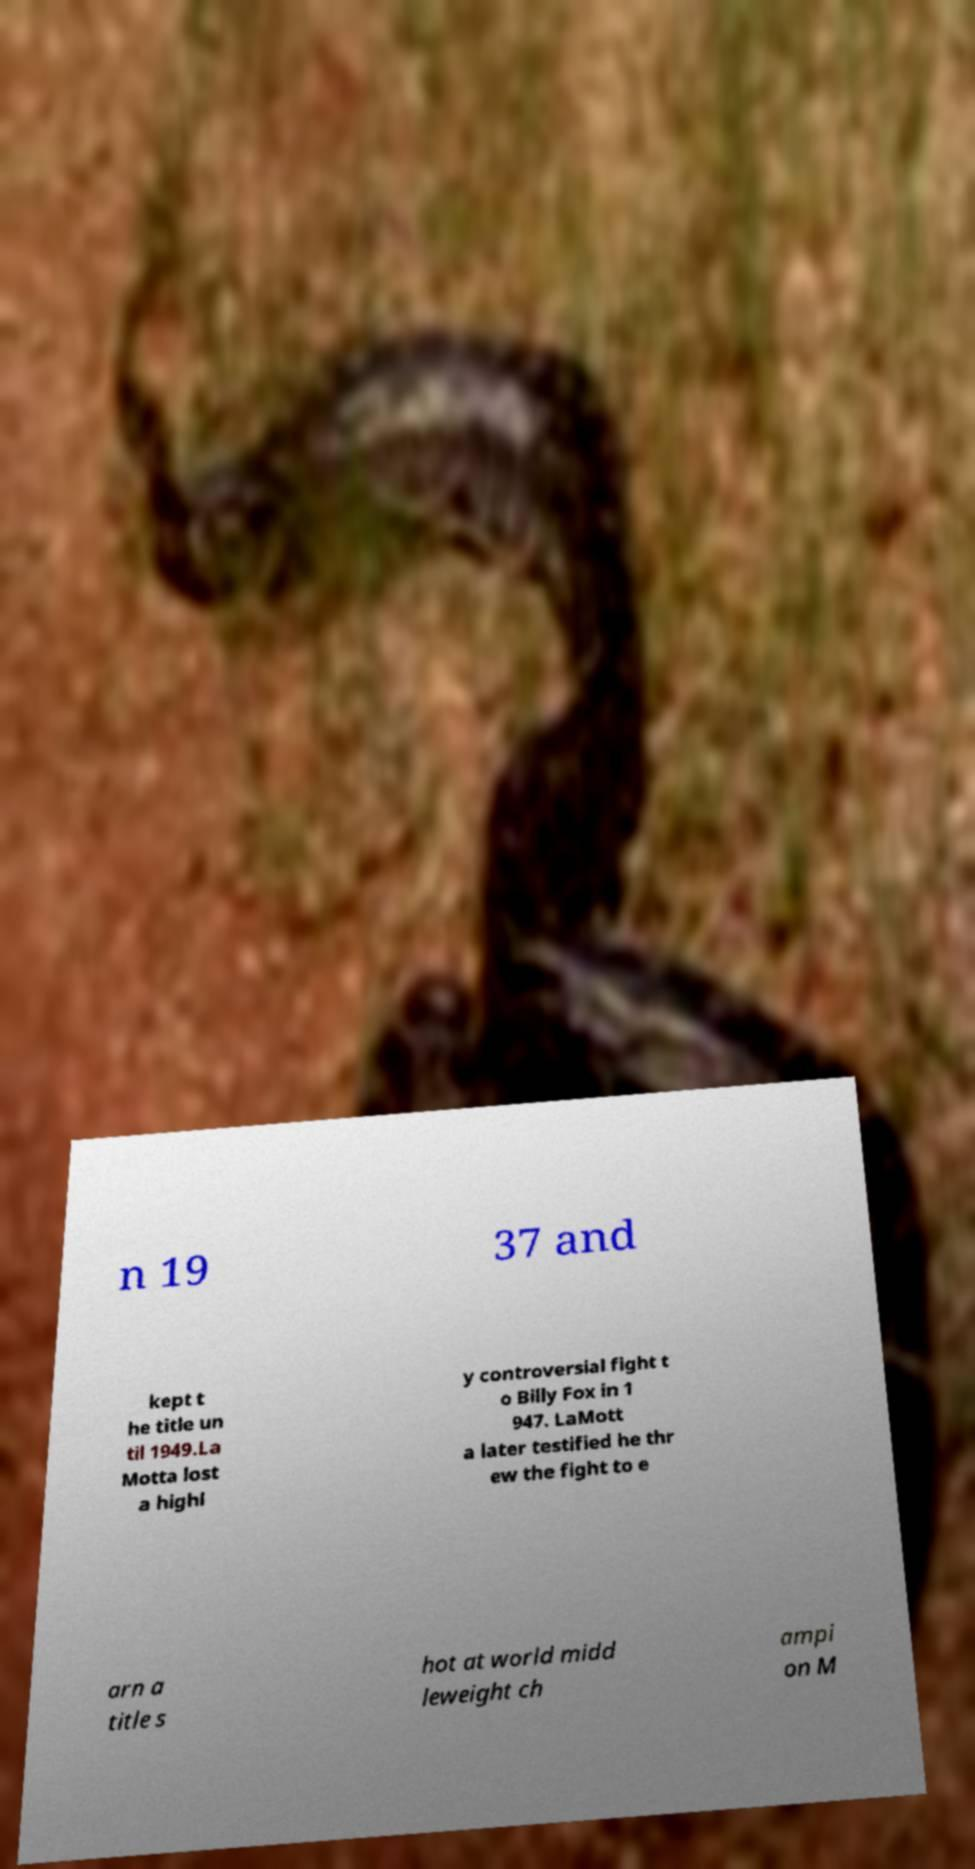There's text embedded in this image that I need extracted. Can you transcribe it verbatim? n 19 37 and kept t he title un til 1949.La Motta lost a highl y controversial fight t o Billy Fox in 1 947. LaMott a later testified he thr ew the fight to e arn a title s hot at world midd leweight ch ampi on M 